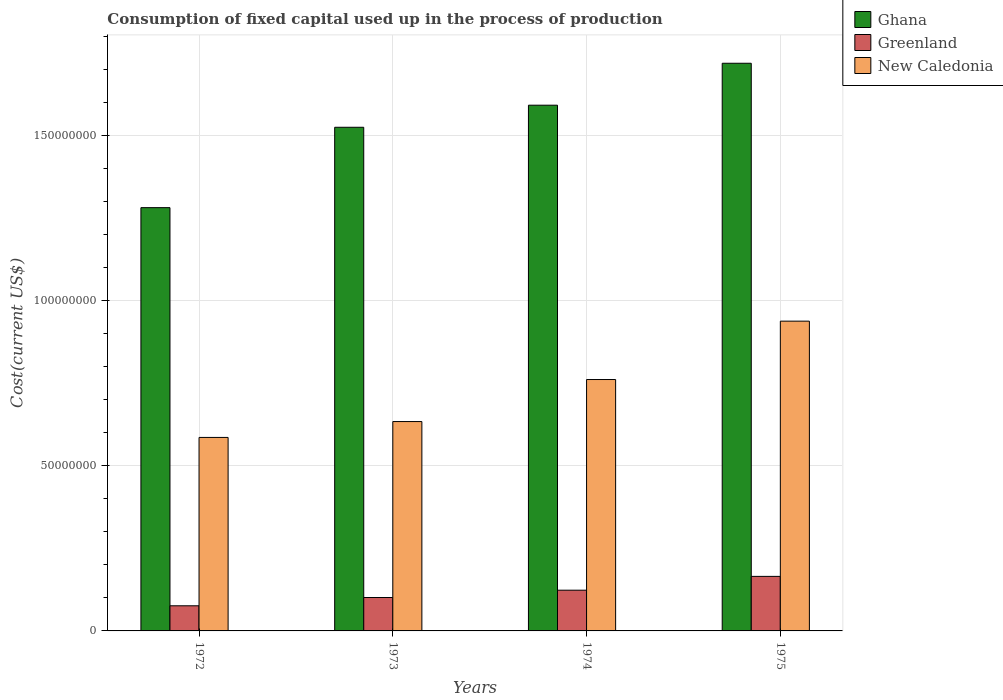How many different coloured bars are there?
Provide a succinct answer. 3. Are the number of bars on each tick of the X-axis equal?
Provide a short and direct response. Yes. How many bars are there on the 2nd tick from the left?
Keep it short and to the point. 3. What is the amount consumed in the process of production in Greenland in 1972?
Provide a short and direct response. 7.60e+06. Across all years, what is the maximum amount consumed in the process of production in Ghana?
Your answer should be compact. 1.72e+08. Across all years, what is the minimum amount consumed in the process of production in Greenland?
Give a very brief answer. 7.60e+06. In which year was the amount consumed in the process of production in Ghana maximum?
Offer a very short reply. 1975. What is the total amount consumed in the process of production in Greenland in the graph?
Ensure brevity in your answer.  4.65e+07. What is the difference between the amount consumed in the process of production in Ghana in 1974 and that in 1975?
Provide a succinct answer. -1.27e+07. What is the difference between the amount consumed in the process of production in Greenland in 1975 and the amount consumed in the process of production in Ghana in 1972?
Ensure brevity in your answer.  -1.12e+08. What is the average amount consumed in the process of production in New Caledonia per year?
Your response must be concise. 7.29e+07. In the year 1975, what is the difference between the amount consumed in the process of production in New Caledonia and amount consumed in the process of production in Greenland?
Offer a very short reply. 7.72e+07. In how many years, is the amount consumed in the process of production in New Caledonia greater than 130000000 US$?
Make the answer very short. 0. What is the ratio of the amount consumed in the process of production in New Caledonia in 1972 to that in 1974?
Your answer should be compact. 0.77. Is the difference between the amount consumed in the process of production in New Caledonia in 1972 and 1973 greater than the difference between the amount consumed in the process of production in Greenland in 1972 and 1973?
Ensure brevity in your answer.  No. What is the difference between the highest and the second highest amount consumed in the process of production in New Caledonia?
Provide a succinct answer. 1.77e+07. What is the difference between the highest and the lowest amount consumed in the process of production in Greenland?
Give a very brief answer. 8.90e+06. In how many years, is the amount consumed in the process of production in Greenland greater than the average amount consumed in the process of production in Greenland taken over all years?
Ensure brevity in your answer.  2. Is the sum of the amount consumed in the process of production in New Caledonia in 1972 and 1973 greater than the maximum amount consumed in the process of production in Greenland across all years?
Offer a terse response. Yes. What does the 1st bar from the left in 1975 represents?
Give a very brief answer. Ghana. What does the 2nd bar from the right in 1974 represents?
Offer a very short reply. Greenland. How many years are there in the graph?
Your answer should be compact. 4. What is the difference between two consecutive major ticks on the Y-axis?
Your answer should be compact. 5.00e+07. Does the graph contain any zero values?
Your answer should be compact. No. Does the graph contain grids?
Your answer should be very brief. Yes. Where does the legend appear in the graph?
Offer a terse response. Top right. How are the legend labels stacked?
Your answer should be compact. Vertical. What is the title of the graph?
Provide a succinct answer. Consumption of fixed capital used up in the process of production. What is the label or title of the X-axis?
Give a very brief answer. Years. What is the label or title of the Y-axis?
Your answer should be compact. Cost(current US$). What is the Cost(current US$) in Ghana in 1972?
Provide a succinct answer. 1.28e+08. What is the Cost(current US$) in Greenland in 1972?
Your response must be concise. 7.60e+06. What is the Cost(current US$) of New Caledonia in 1972?
Provide a short and direct response. 5.85e+07. What is the Cost(current US$) of Ghana in 1973?
Offer a terse response. 1.52e+08. What is the Cost(current US$) in Greenland in 1973?
Your answer should be compact. 1.01e+07. What is the Cost(current US$) of New Caledonia in 1973?
Offer a very short reply. 6.33e+07. What is the Cost(current US$) of Ghana in 1974?
Provide a short and direct response. 1.59e+08. What is the Cost(current US$) in Greenland in 1974?
Provide a succinct answer. 1.23e+07. What is the Cost(current US$) of New Caledonia in 1974?
Provide a short and direct response. 7.61e+07. What is the Cost(current US$) of Ghana in 1975?
Your response must be concise. 1.72e+08. What is the Cost(current US$) of Greenland in 1975?
Your answer should be very brief. 1.65e+07. What is the Cost(current US$) in New Caledonia in 1975?
Offer a terse response. 9.37e+07. Across all years, what is the maximum Cost(current US$) of Ghana?
Offer a terse response. 1.72e+08. Across all years, what is the maximum Cost(current US$) of Greenland?
Keep it short and to the point. 1.65e+07. Across all years, what is the maximum Cost(current US$) of New Caledonia?
Ensure brevity in your answer.  9.37e+07. Across all years, what is the minimum Cost(current US$) in Ghana?
Your answer should be very brief. 1.28e+08. Across all years, what is the minimum Cost(current US$) in Greenland?
Give a very brief answer. 7.60e+06. Across all years, what is the minimum Cost(current US$) of New Caledonia?
Offer a terse response. 5.85e+07. What is the total Cost(current US$) in Ghana in the graph?
Keep it short and to the point. 6.11e+08. What is the total Cost(current US$) of Greenland in the graph?
Provide a succinct answer. 4.65e+07. What is the total Cost(current US$) in New Caledonia in the graph?
Your answer should be very brief. 2.92e+08. What is the difference between the Cost(current US$) in Ghana in 1972 and that in 1973?
Make the answer very short. -2.43e+07. What is the difference between the Cost(current US$) in Greenland in 1972 and that in 1973?
Make the answer very short. -2.50e+06. What is the difference between the Cost(current US$) in New Caledonia in 1972 and that in 1973?
Offer a very short reply. -4.80e+06. What is the difference between the Cost(current US$) of Ghana in 1972 and that in 1974?
Keep it short and to the point. -3.10e+07. What is the difference between the Cost(current US$) of Greenland in 1972 and that in 1974?
Make the answer very short. -4.72e+06. What is the difference between the Cost(current US$) of New Caledonia in 1972 and that in 1974?
Your answer should be very brief. -1.75e+07. What is the difference between the Cost(current US$) of Ghana in 1972 and that in 1975?
Keep it short and to the point. -4.37e+07. What is the difference between the Cost(current US$) of Greenland in 1972 and that in 1975?
Offer a terse response. -8.90e+06. What is the difference between the Cost(current US$) in New Caledonia in 1972 and that in 1975?
Provide a short and direct response. -3.52e+07. What is the difference between the Cost(current US$) in Ghana in 1973 and that in 1974?
Ensure brevity in your answer.  -6.68e+06. What is the difference between the Cost(current US$) in Greenland in 1973 and that in 1974?
Your response must be concise. -2.21e+06. What is the difference between the Cost(current US$) of New Caledonia in 1973 and that in 1974?
Your response must be concise. -1.27e+07. What is the difference between the Cost(current US$) in Ghana in 1973 and that in 1975?
Make the answer very short. -1.94e+07. What is the difference between the Cost(current US$) in Greenland in 1973 and that in 1975?
Offer a very short reply. -6.39e+06. What is the difference between the Cost(current US$) of New Caledonia in 1973 and that in 1975?
Provide a short and direct response. -3.04e+07. What is the difference between the Cost(current US$) of Ghana in 1974 and that in 1975?
Give a very brief answer. -1.27e+07. What is the difference between the Cost(current US$) in Greenland in 1974 and that in 1975?
Make the answer very short. -4.18e+06. What is the difference between the Cost(current US$) of New Caledonia in 1974 and that in 1975?
Provide a succinct answer. -1.77e+07. What is the difference between the Cost(current US$) of Ghana in 1972 and the Cost(current US$) of Greenland in 1973?
Your answer should be very brief. 1.18e+08. What is the difference between the Cost(current US$) in Ghana in 1972 and the Cost(current US$) in New Caledonia in 1973?
Provide a succinct answer. 6.47e+07. What is the difference between the Cost(current US$) of Greenland in 1972 and the Cost(current US$) of New Caledonia in 1973?
Provide a succinct answer. -5.57e+07. What is the difference between the Cost(current US$) of Ghana in 1972 and the Cost(current US$) of Greenland in 1974?
Give a very brief answer. 1.16e+08. What is the difference between the Cost(current US$) in Ghana in 1972 and the Cost(current US$) in New Caledonia in 1974?
Ensure brevity in your answer.  5.20e+07. What is the difference between the Cost(current US$) of Greenland in 1972 and the Cost(current US$) of New Caledonia in 1974?
Offer a very short reply. -6.85e+07. What is the difference between the Cost(current US$) of Ghana in 1972 and the Cost(current US$) of Greenland in 1975?
Make the answer very short. 1.12e+08. What is the difference between the Cost(current US$) in Ghana in 1972 and the Cost(current US$) in New Caledonia in 1975?
Provide a short and direct response. 3.43e+07. What is the difference between the Cost(current US$) of Greenland in 1972 and the Cost(current US$) of New Caledonia in 1975?
Offer a terse response. -8.61e+07. What is the difference between the Cost(current US$) of Ghana in 1973 and the Cost(current US$) of Greenland in 1974?
Provide a succinct answer. 1.40e+08. What is the difference between the Cost(current US$) of Ghana in 1973 and the Cost(current US$) of New Caledonia in 1974?
Provide a short and direct response. 7.63e+07. What is the difference between the Cost(current US$) in Greenland in 1973 and the Cost(current US$) in New Caledonia in 1974?
Your answer should be very brief. -6.60e+07. What is the difference between the Cost(current US$) in Ghana in 1973 and the Cost(current US$) in Greenland in 1975?
Make the answer very short. 1.36e+08. What is the difference between the Cost(current US$) in Ghana in 1973 and the Cost(current US$) in New Caledonia in 1975?
Your answer should be very brief. 5.87e+07. What is the difference between the Cost(current US$) of Greenland in 1973 and the Cost(current US$) of New Caledonia in 1975?
Give a very brief answer. -8.36e+07. What is the difference between the Cost(current US$) in Ghana in 1974 and the Cost(current US$) in Greenland in 1975?
Offer a terse response. 1.43e+08. What is the difference between the Cost(current US$) of Ghana in 1974 and the Cost(current US$) of New Caledonia in 1975?
Provide a short and direct response. 6.53e+07. What is the difference between the Cost(current US$) of Greenland in 1974 and the Cost(current US$) of New Caledonia in 1975?
Your answer should be compact. -8.14e+07. What is the average Cost(current US$) of Ghana per year?
Make the answer very short. 1.53e+08. What is the average Cost(current US$) in Greenland per year?
Provide a short and direct response. 1.16e+07. What is the average Cost(current US$) of New Caledonia per year?
Ensure brevity in your answer.  7.29e+07. In the year 1972, what is the difference between the Cost(current US$) of Ghana and Cost(current US$) of Greenland?
Offer a terse response. 1.20e+08. In the year 1972, what is the difference between the Cost(current US$) in Ghana and Cost(current US$) in New Caledonia?
Make the answer very short. 6.95e+07. In the year 1972, what is the difference between the Cost(current US$) in Greenland and Cost(current US$) in New Caledonia?
Give a very brief answer. -5.09e+07. In the year 1973, what is the difference between the Cost(current US$) in Ghana and Cost(current US$) in Greenland?
Ensure brevity in your answer.  1.42e+08. In the year 1973, what is the difference between the Cost(current US$) in Ghana and Cost(current US$) in New Caledonia?
Your answer should be compact. 8.90e+07. In the year 1973, what is the difference between the Cost(current US$) of Greenland and Cost(current US$) of New Caledonia?
Offer a terse response. -5.32e+07. In the year 1974, what is the difference between the Cost(current US$) in Ghana and Cost(current US$) in Greenland?
Offer a terse response. 1.47e+08. In the year 1974, what is the difference between the Cost(current US$) of Ghana and Cost(current US$) of New Caledonia?
Make the answer very short. 8.30e+07. In the year 1974, what is the difference between the Cost(current US$) of Greenland and Cost(current US$) of New Caledonia?
Provide a succinct answer. -6.37e+07. In the year 1975, what is the difference between the Cost(current US$) in Ghana and Cost(current US$) in Greenland?
Offer a very short reply. 1.55e+08. In the year 1975, what is the difference between the Cost(current US$) in Ghana and Cost(current US$) in New Caledonia?
Your answer should be compact. 7.80e+07. In the year 1975, what is the difference between the Cost(current US$) of Greenland and Cost(current US$) of New Caledonia?
Your answer should be compact. -7.72e+07. What is the ratio of the Cost(current US$) of Ghana in 1972 to that in 1973?
Your answer should be very brief. 0.84. What is the ratio of the Cost(current US$) of Greenland in 1972 to that in 1973?
Provide a short and direct response. 0.75. What is the ratio of the Cost(current US$) of New Caledonia in 1972 to that in 1973?
Your answer should be very brief. 0.92. What is the ratio of the Cost(current US$) in Ghana in 1972 to that in 1974?
Offer a very short reply. 0.81. What is the ratio of the Cost(current US$) in Greenland in 1972 to that in 1974?
Give a very brief answer. 0.62. What is the ratio of the Cost(current US$) in New Caledonia in 1972 to that in 1974?
Keep it short and to the point. 0.77. What is the ratio of the Cost(current US$) of Ghana in 1972 to that in 1975?
Offer a terse response. 0.75. What is the ratio of the Cost(current US$) of Greenland in 1972 to that in 1975?
Make the answer very short. 0.46. What is the ratio of the Cost(current US$) of New Caledonia in 1972 to that in 1975?
Keep it short and to the point. 0.62. What is the ratio of the Cost(current US$) in Ghana in 1973 to that in 1974?
Your response must be concise. 0.96. What is the ratio of the Cost(current US$) of Greenland in 1973 to that in 1974?
Your answer should be very brief. 0.82. What is the ratio of the Cost(current US$) of New Caledonia in 1973 to that in 1974?
Ensure brevity in your answer.  0.83. What is the ratio of the Cost(current US$) of Ghana in 1973 to that in 1975?
Your answer should be compact. 0.89. What is the ratio of the Cost(current US$) in Greenland in 1973 to that in 1975?
Your answer should be compact. 0.61. What is the ratio of the Cost(current US$) in New Caledonia in 1973 to that in 1975?
Provide a short and direct response. 0.68. What is the ratio of the Cost(current US$) in Ghana in 1974 to that in 1975?
Provide a short and direct response. 0.93. What is the ratio of the Cost(current US$) in Greenland in 1974 to that in 1975?
Provide a succinct answer. 0.75. What is the ratio of the Cost(current US$) in New Caledonia in 1974 to that in 1975?
Your response must be concise. 0.81. What is the difference between the highest and the second highest Cost(current US$) in Ghana?
Give a very brief answer. 1.27e+07. What is the difference between the highest and the second highest Cost(current US$) in Greenland?
Your answer should be compact. 4.18e+06. What is the difference between the highest and the second highest Cost(current US$) of New Caledonia?
Make the answer very short. 1.77e+07. What is the difference between the highest and the lowest Cost(current US$) of Ghana?
Ensure brevity in your answer.  4.37e+07. What is the difference between the highest and the lowest Cost(current US$) in Greenland?
Make the answer very short. 8.90e+06. What is the difference between the highest and the lowest Cost(current US$) in New Caledonia?
Offer a very short reply. 3.52e+07. 